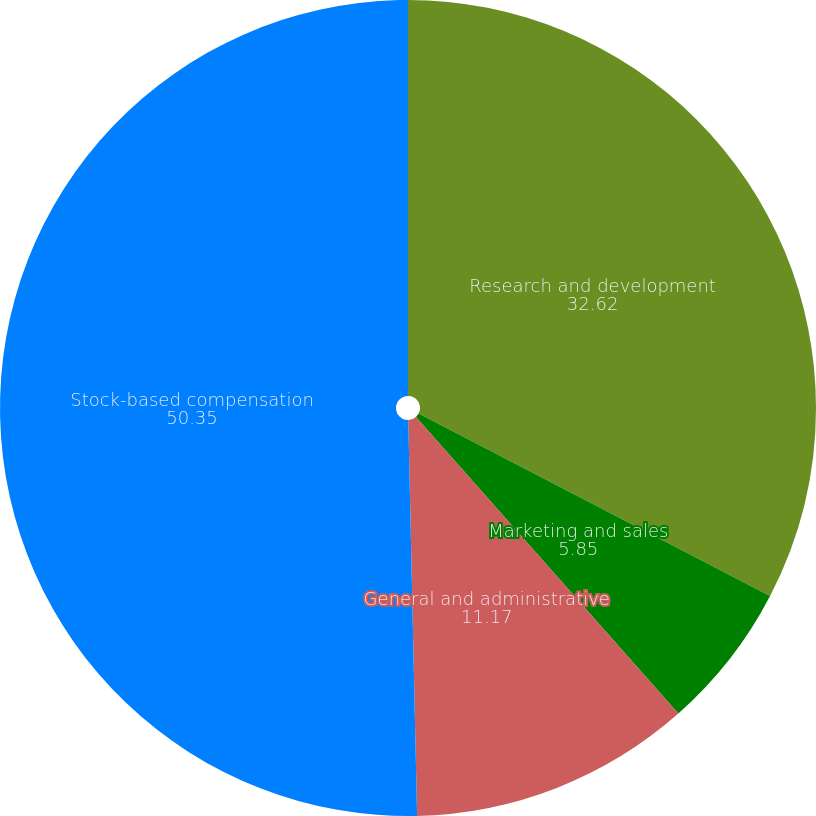Convert chart. <chart><loc_0><loc_0><loc_500><loc_500><pie_chart><fcel>Research and development<fcel>Marketing and sales<fcel>General and administrative<fcel>Stock-based compensation<nl><fcel>32.62%<fcel>5.85%<fcel>11.17%<fcel>50.35%<nl></chart> 